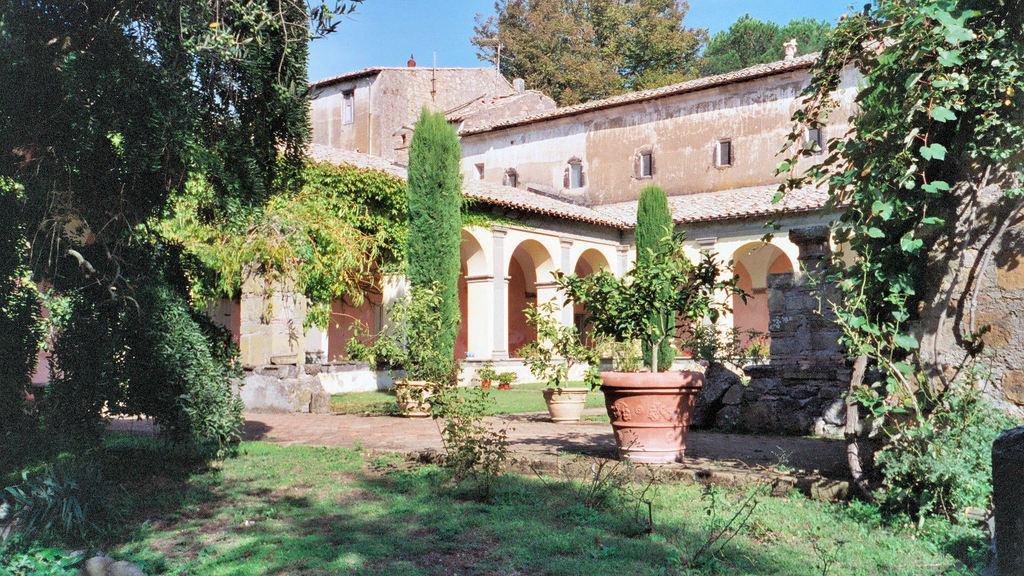Describe this image in one or two sentences. In this image there is a building, trees, plants, plant pots, grass on the surface. In the background there is the sky. 